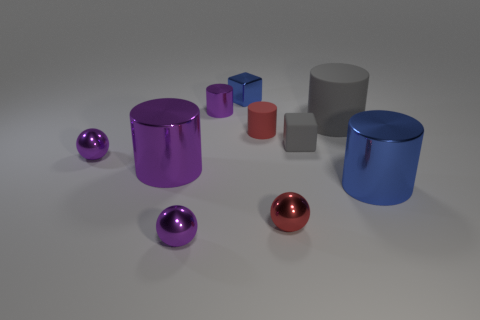Do the red ball and the gray block have the same size?
Make the answer very short. Yes. There is a cylinder that is both in front of the small matte cylinder and to the left of the blue cube; what size is it?
Give a very brief answer. Large. What number of shiny things are either purple cylinders or tiny purple balls?
Your answer should be very brief. 4. Is the number of small red shiny objects behind the gray matte cylinder greater than the number of small cylinders?
Provide a short and direct response. No. What material is the block that is in front of the tiny blue shiny cube?
Give a very brief answer. Rubber. How many gray blocks are made of the same material as the small red cylinder?
Give a very brief answer. 1. The small thing that is on the right side of the metallic cube and to the left of the small red metal sphere has what shape?
Your response must be concise. Cylinder. How many objects are either purple shiny objects that are behind the tiny red cylinder or blue things that are behind the large gray matte cylinder?
Your answer should be very brief. 2. Are there the same number of purple cylinders to the right of the tiny gray matte object and tiny red metal objects behind the big purple metallic object?
Offer a terse response. Yes. There is a large metallic thing on the right side of the ball that is in front of the tiny red sphere; what shape is it?
Your response must be concise. Cylinder. 